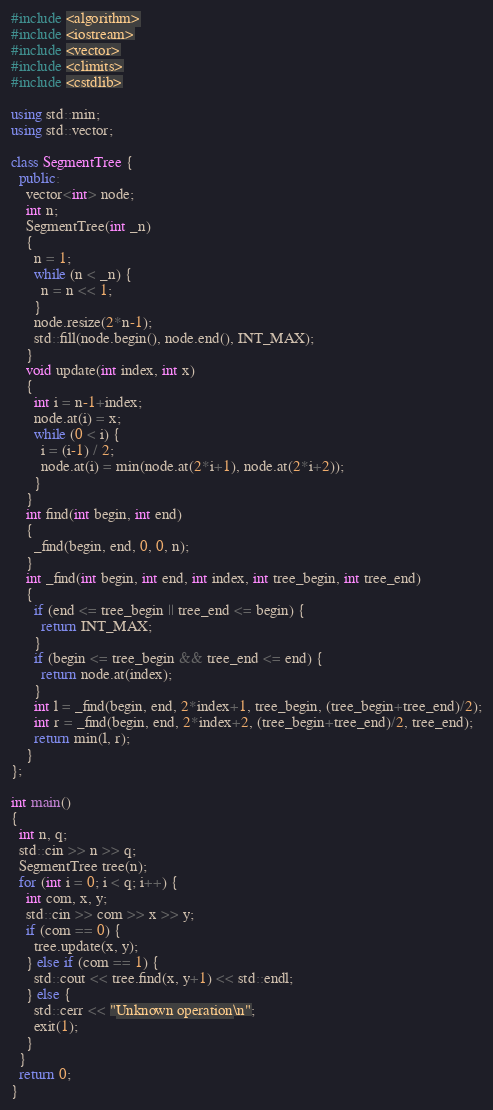Convert code to text. <code><loc_0><loc_0><loc_500><loc_500><_C++_>#include <algorithm>
#include <iostream>
#include <vector>
#include <climits>
#include <cstdlib>

using std::min;
using std::vector;

class SegmentTree {
  public:
    vector<int> node;
    int n;
    SegmentTree(int _n)
    {
      n = 1;
      while (n < _n) {
        n = n << 1;
      }
      node.resize(2*n-1);
      std::fill(node.begin(), node.end(), INT_MAX);
    }
    void update(int index, int x)
    {
      int i = n-1+index;
      node.at(i) = x;
      while (0 < i) {
        i = (i-1) / 2;
        node.at(i) = min(node.at(2*i+1), node.at(2*i+2));
      }
    }
    int find(int begin, int end)
    {
      _find(begin, end, 0, 0, n);
    }
    int _find(int begin, int end, int index, int tree_begin, int tree_end)
    {
      if (end <= tree_begin || tree_end <= begin) {
        return INT_MAX;
      }
      if (begin <= tree_begin && tree_end <= end) {
        return node.at(index);
      }
      int l = _find(begin, end, 2*index+1, tree_begin, (tree_begin+tree_end)/2);
      int r = _find(begin, end, 2*index+2, (tree_begin+tree_end)/2, tree_end);
      return min(l, r);
    }
};

int main()
{
  int n, q;
  std::cin >> n >> q;
  SegmentTree tree(n);
  for (int i = 0; i < q; i++) {
    int com, x, y;
    std::cin >> com >> x >> y;
    if (com == 0) {
      tree.update(x, y);
    } else if (com == 1) {
      std::cout << tree.find(x, y+1) << std::endl;
    } else {
      std::cerr << "Unknown operation\n";
      exit(1);
    }
  }
  return 0;
}

</code> 